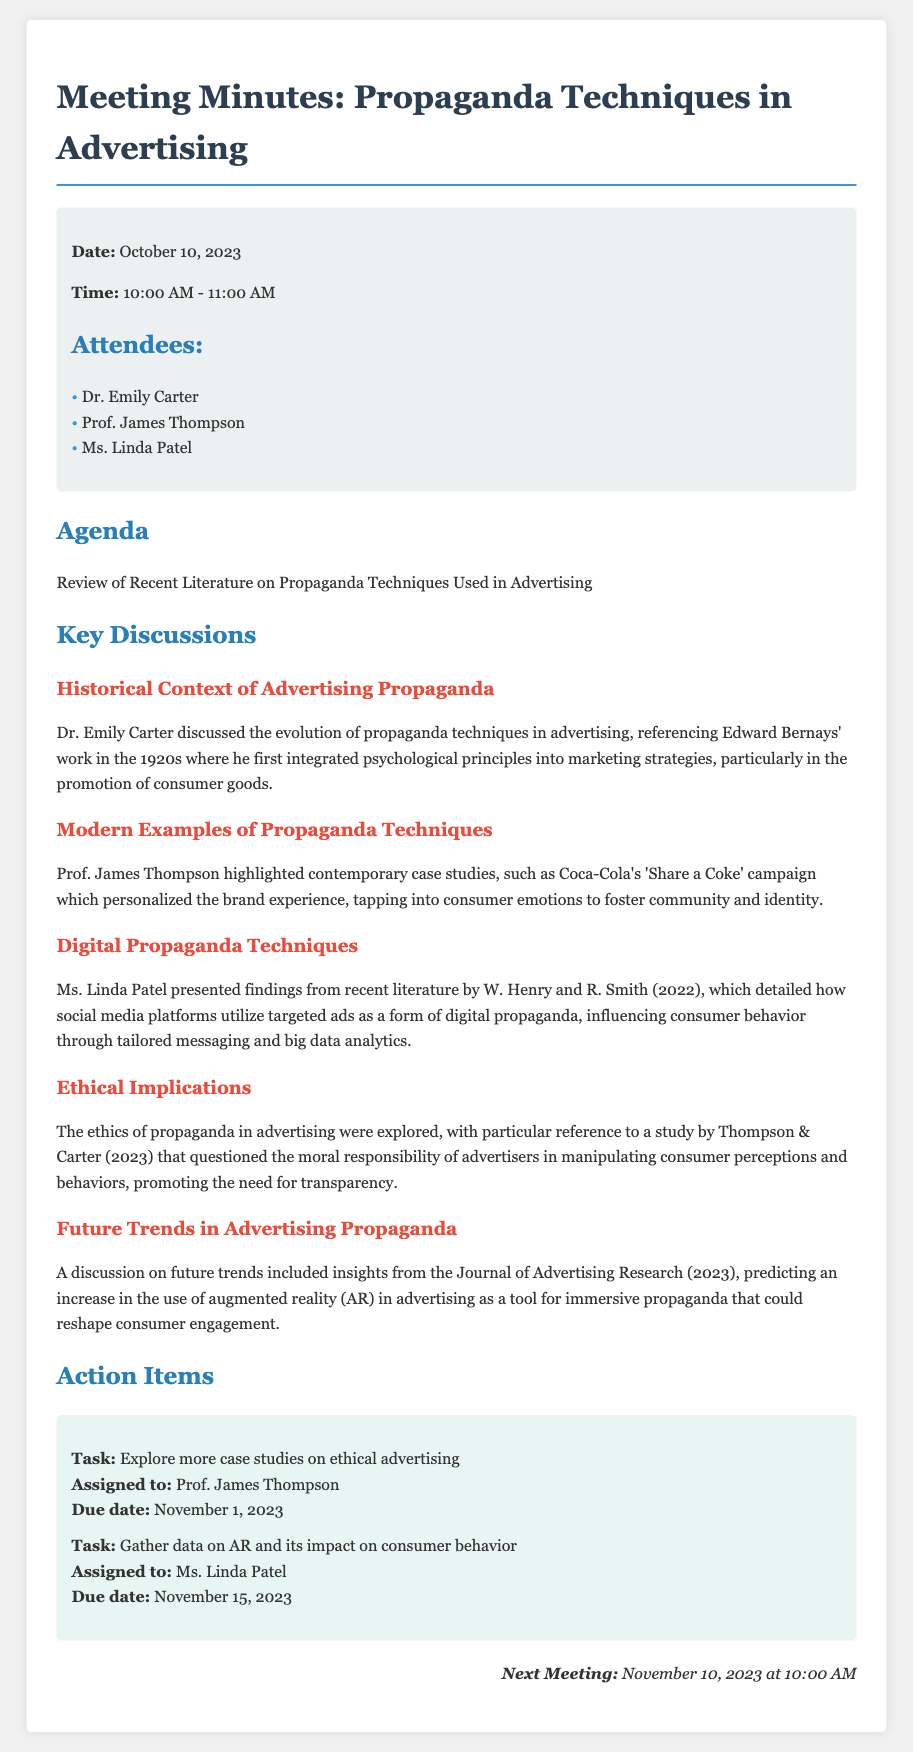What is the date of the meeting? The date of the meeting is stated in the meta-info section of the document.
Answer: October 10, 2023 Who discussed the historical context of advertising propaganda? The key discussions section lists Dr. Emily Carter as the speaker on this topic.
Answer: Dr. Emily Carter What was a modern example of propaganda techniques mentioned? The document references Coca-Cola's campaign as a contemporary case study.
Answer: Coca-Cola's 'Share a Coke' campaign What did Ms. Linda Patel present findings on? The key discussions include her presentation on how social media platforms utilize targeted ads as a form of digital propaganda.
Answer: Digital propaganda techniques When is the next meeting scheduled? The next meeting date is specified in the document's last section.
Answer: November 10, 2023 What is the task assigned to Prof. James Thompson? The action items section details the tasks assigned to attendees, with a specific mention for Prof. Thompson.
Answer: Explore more case studies on ethical advertising What is the due date for Ms. Linda Patel's task? The due date for her task is listed in the action items section of the document.
Answer: November 15, 2023 What were the ethical implications explored in the meeting? The document indicates that the ethics of propaganda in advertising were debated, based on a specific study.
Answer: Moral responsibility of advertisers How did the meeting address future trends in advertising propaganda? The discussions included insights from the Journal of Advertising Research on a predicted increase in specific technologies in advertising.
Answer: Augmented reality (AR) 